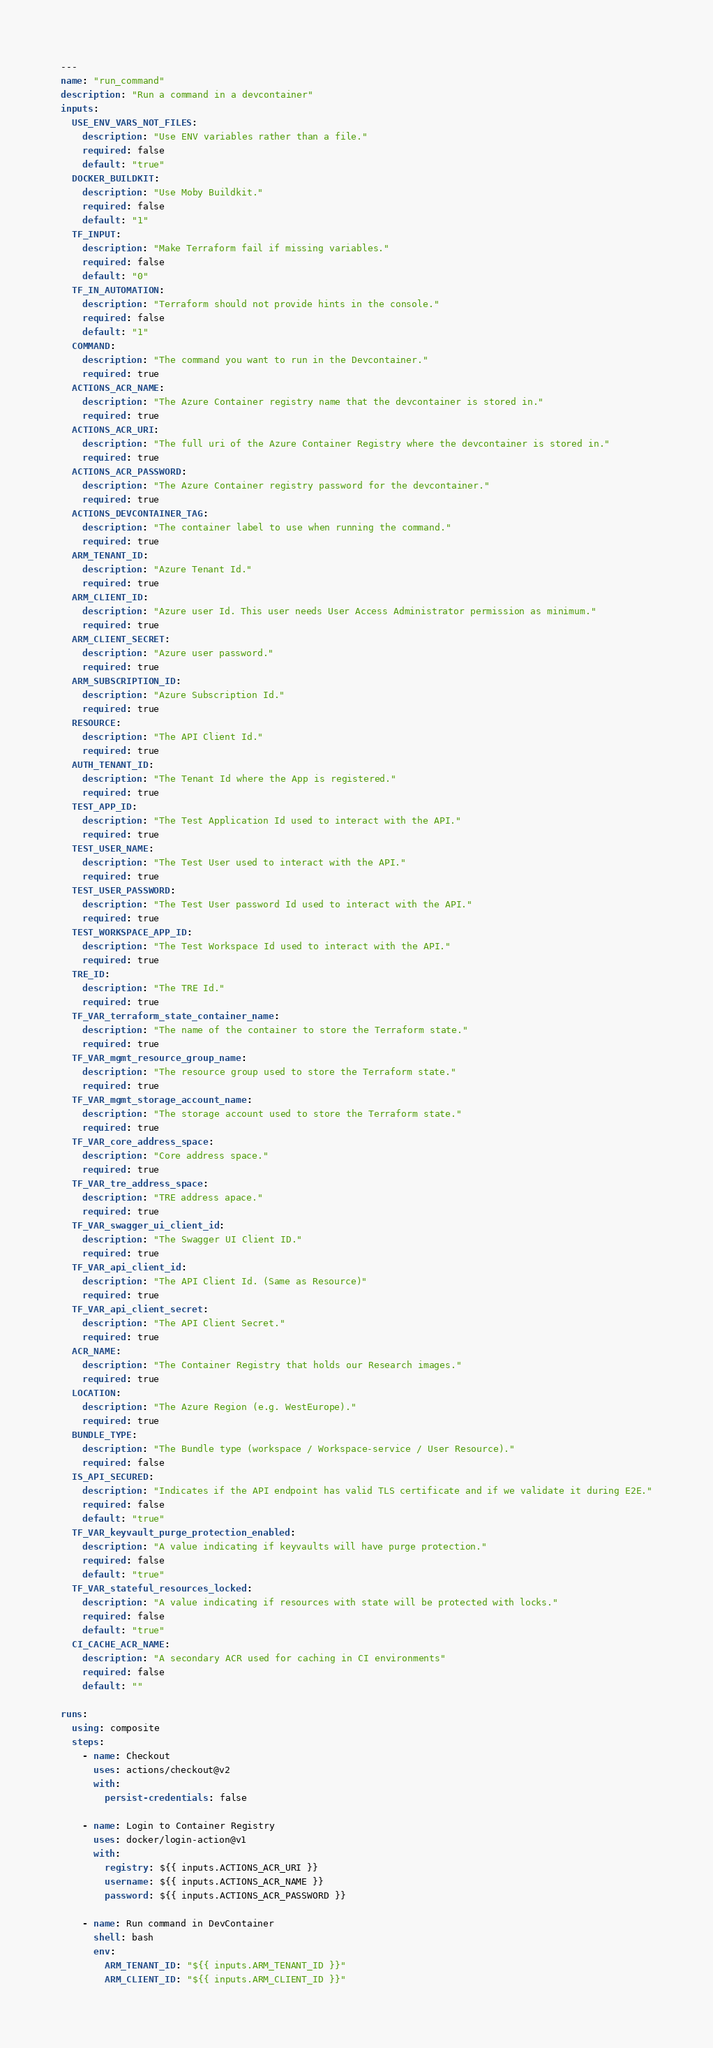Convert code to text. <code><loc_0><loc_0><loc_500><loc_500><_YAML_>---
name: "run_command"
description: "Run a command in a devcontainer"
inputs:
  USE_ENV_VARS_NOT_FILES:
    description: "Use ENV variables rather than a file."
    required: false
    default: "true"
  DOCKER_BUILDKIT:
    description: "Use Moby Buildkit."
    required: false
    default: "1"
  TF_INPUT:
    description: "Make Terraform fail if missing variables."
    required: false
    default: "0"
  TF_IN_AUTOMATION:
    description: "Terraform should not provide hints in the console."
    required: false
    default: "1"
  COMMAND:
    description: "The command you want to run in the Devcontainer."
    required: true
  ACTIONS_ACR_NAME:
    description: "The Azure Container registry name that the devcontainer is stored in."
    required: true
  ACTIONS_ACR_URI:
    description: "The full uri of the Azure Container Registry where the devcontainer is stored in."
    required: true
  ACTIONS_ACR_PASSWORD:
    description: "The Azure Container registry password for the devcontainer."
    required: true
  ACTIONS_DEVCONTAINER_TAG:
    description: "The container label to use when running the command."
    required: true
  ARM_TENANT_ID:
    description: "Azure Tenant Id."
    required: true
  ARM_CLIENT_ID:
    description: "Azure user Id. This user needs User Access Administrator permission as minimum."
    required: true
  ARM_CLIENT_SECRET:
    description: "Azure user password."
    required: true
  ARM_SUBSCRIPTION_ID:
    description: "Azure Subscription Id."
    required: true
  RESOURCE:
    description: "The API Client Id."
    required: true
  AUTH_TENANT_ID:
    description: "The Tenant Id where the App is registered."
    required: true
  TEST_APP_ID:
    description: "The Test Application Id used to interact with the API."
    required: true
  TEST_USER_NAME:
    description: "The Test User used to interact with the API."
    required: true
  TEST_USER_PASSWORD:
    description: "The Test User password Id used to interact with the API."
    required: true
  TEST_WORKSPACE_APP_ID:
    description: "The Test Workspace Id used to interact with the API."
    required: true
  TRE_ID:
    description: "The TRE Id."
    required: true
  TF_VAR_terraform_state_container_name:
    description: "The name of the container to store the Terraform state."
    required: true
  TF_VAR_mgmt_resource_group_name:
    description: "The resource group used to store the Terraform state."
    required: true
  TF_VAR_mgmt_storage_account_name:
    description: "The storage account used to store the Terraform state."
    required: true
  TF_VAR_core_address_space:
    description: "Core address space."
    required: true
  TF_VAR_tre_address_space:
    description: "TRE address apace."
    required: true
  TF_VAR_swagger_ui_client_id:
    description: "The Swagger UI Client ID."
    required: true
  TF_VAR_api_client_id:
    description: "The API Client Id. (Same as Resource)"
    required: true
  TF_VAR_api_client_secret:
    description: "The API Client Secret."
    required: true
  ACR_NAME:
    description: "The Container Registry that holds our Research images."
    required: true
  LOCATION:
    description: "The Azure Region (e.g. WestEurope)."
    required: true
  BUNDLE_TYPE:
    description: "The Bundle type (workspace / Workspace-service / User Resource)."
    required: false
  IS_API_SECURED:
    description: "Indicates if the API endpoint has valid TLS certificate and if we validate it during E2E."
    required: false
    default: "true"
  TF_VAR_keyvault_purge_protection_enabled:
    description: "A value indicating if keyvaults will have purge protection."
    required: false
    default: "true"
  TF_VAR_stateful_resources_locked:
    description: "A value indicating if resources with state will be protected with locks."
    required: false
    default: "true"
  CI_CACHE_ACR_NAME:
    description: "A secondary ACR used for caching in CI environments"
    required: false
    default: ""

runs:
  using: composite
  steps:
    - name: Checkout
      uses: actions/checkout@v2
      with:
        persist-credentials: false

    - name: Login to Container Registry
      uses: docker/login-action@v1
      with:
        registry: ${{ inputs.ACTIONS_ACR_URI }}
        username: ${{ inputs.ACTIONS_ACR_NAME }}
        password: ${{ inputs.ACTIONS_ACR_PASSWORD }}

    - name: Run command in DevContainer
      shell: bash
      env:
        ARM_TENANT_ID: "${{ inputs.ARM_TENANT_ID }}"
        ARM_CLIENT_ID: "${{ inputs.ARM_CLIENT_ID }}"</code> 